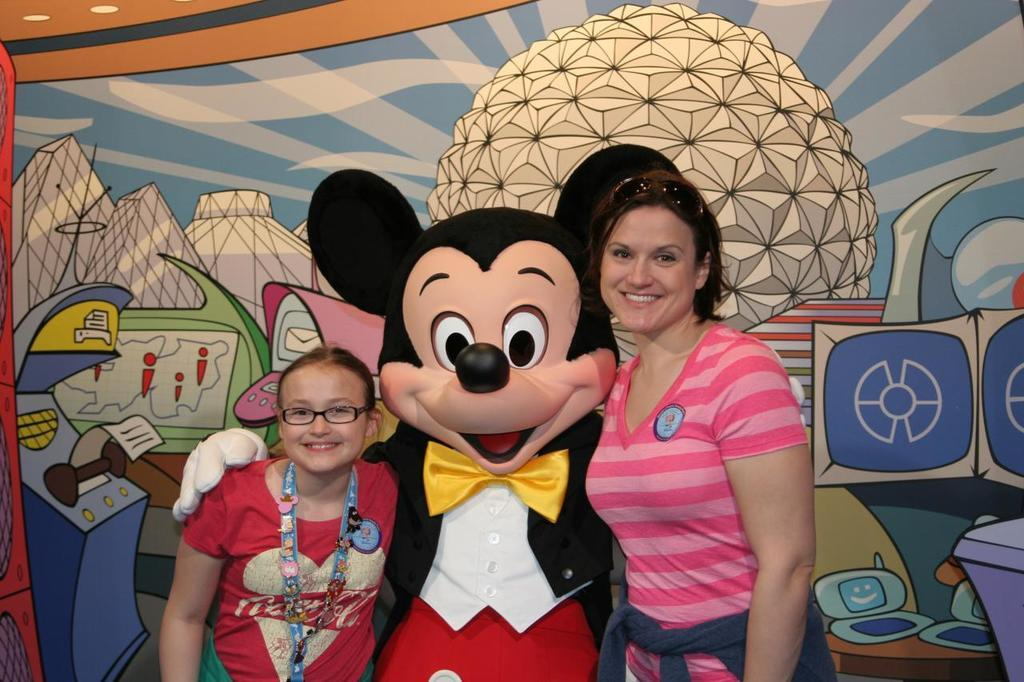How many people are in the image? There are three people in the image. What is unique about the middle person's attire? The middle person is wearing a costume. What can be seen in the background of the image? There is a painting visible in the background. What is the position of the earth in the image? The image does not depict the earth; it features three people and a painting in the background. 